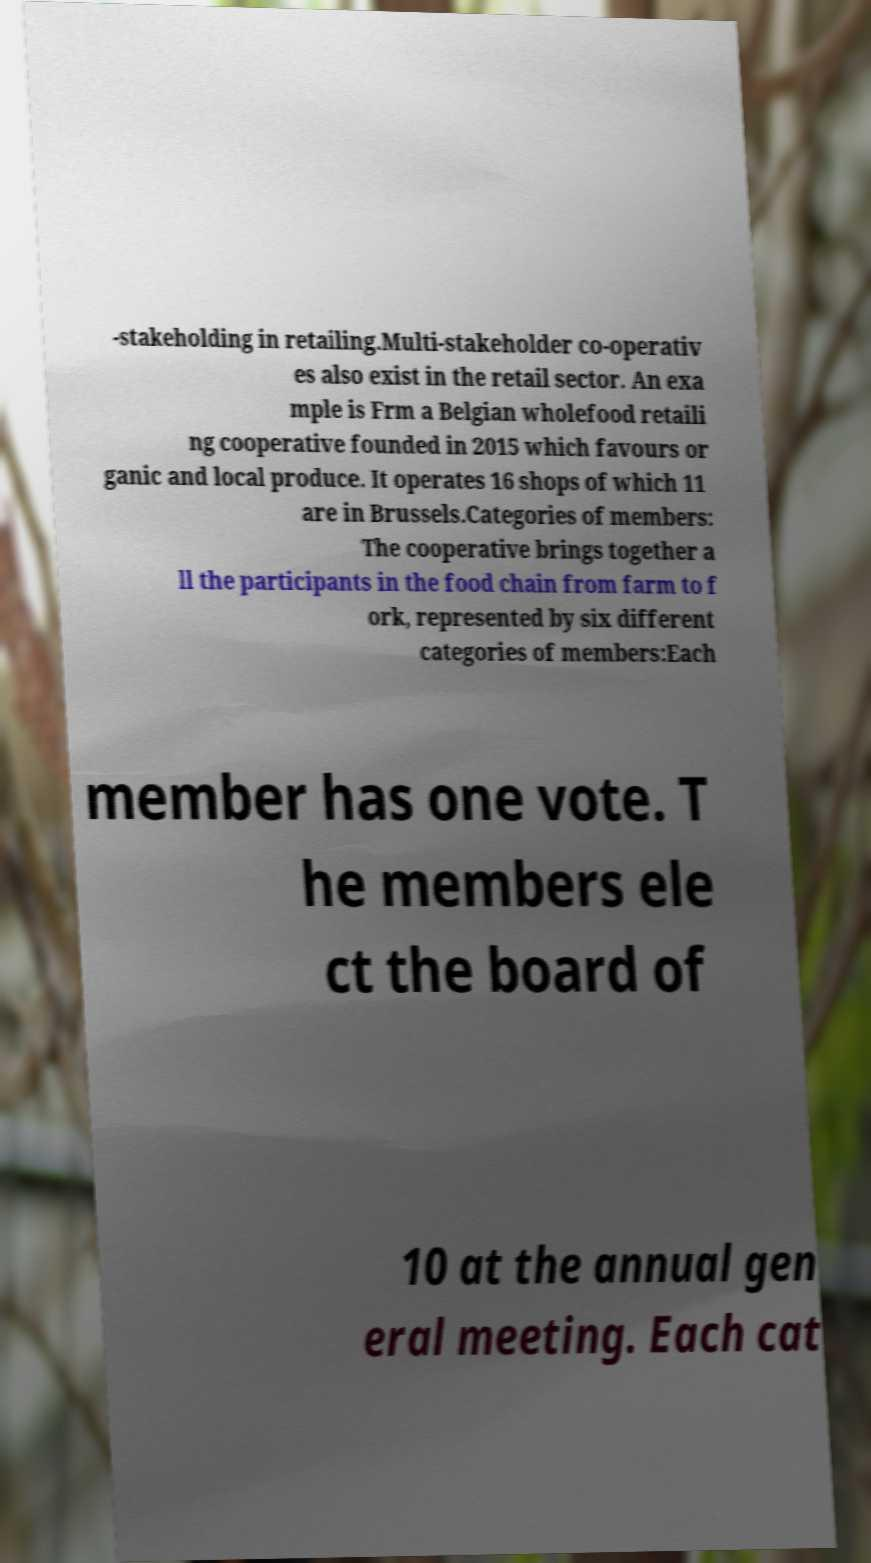Please identify and transcribe the text found in this image. -stakeholding in retailing.Multi-stakeholder co-operativ es also exist in the retail sector. An exa mple is Frm a Belgian wholefood retaili ng cooperative founded in 2015 which favours or ganic and local produce. It operates 16 shops of which 11 are in Brussels.Categories of members: The cooperative brings together a ll the participants in the food chain from farm to f ork, represented by six different categories of members:Each member has one vote. T he members ele ct the board of 10 at the annual gen eral meeting. Each cat 